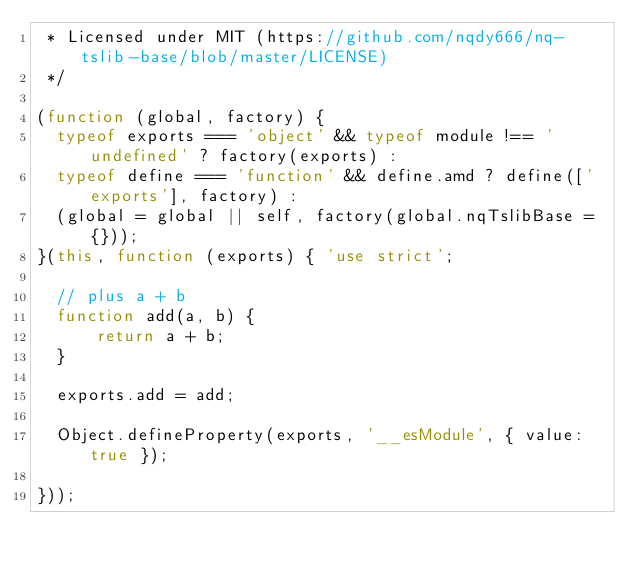<code> <loc_0><loc_0><loc_500><loc_500><_JavaScript_> * Licensed under MIT (https://github.com/nqdy666/nq-tslib-base/blob/master/LICENSE)
 */

(function (global, factory) {
  typeof exports === 'object' && typeof module !== 'undefined' ? factory(exports) :
  typeof define === 'function' && define.amd ? define(['exports'], factory) :
  (global = global || self, factory(global.nqTslibBase = {}));
}(this, function (exports) { 'use strict';

  // plus a + b
  function add(a, b) {
      return a + b;
  }

  exports.add = add;

  Object.defineProperty(exports, '__esModule', { value: true });

}));
</code> 